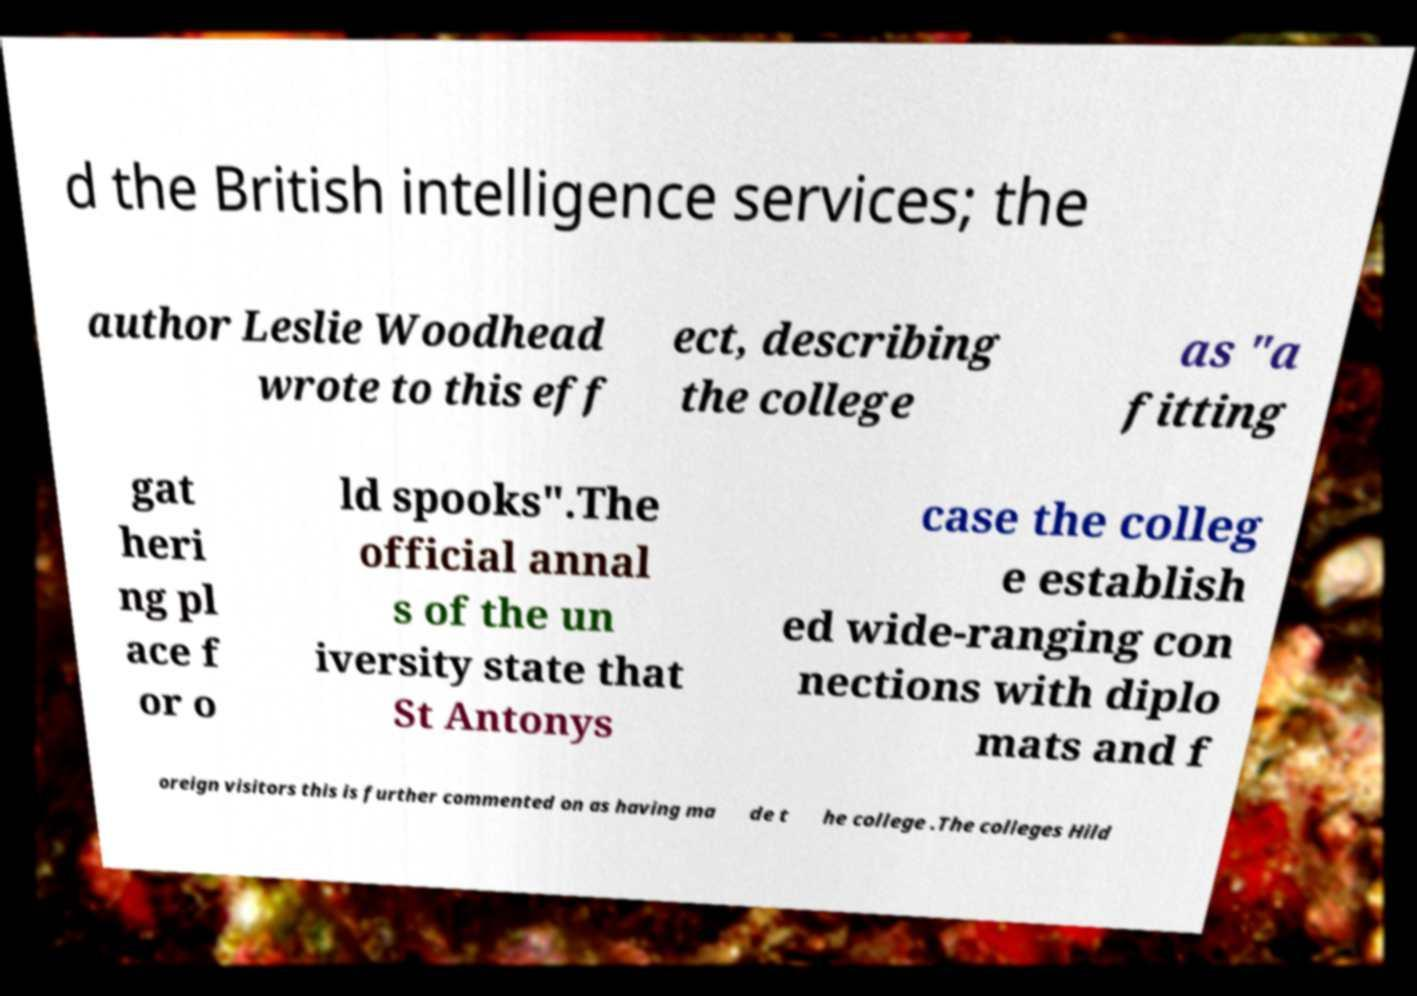Could you extract and type out the text from this image? d the British intelligence services; the author Leslie Woodhead wrote to this eff ect, describing the college as "a fitting gat heri ng pl ace f or o ld spooks".The official annal s of the un iversity state that St Antonys case the colleg e establish ed wide-ranging con nections with diplo mats and f oreign visitors this is further commented on as having ma de t he college .The colleges Hild 